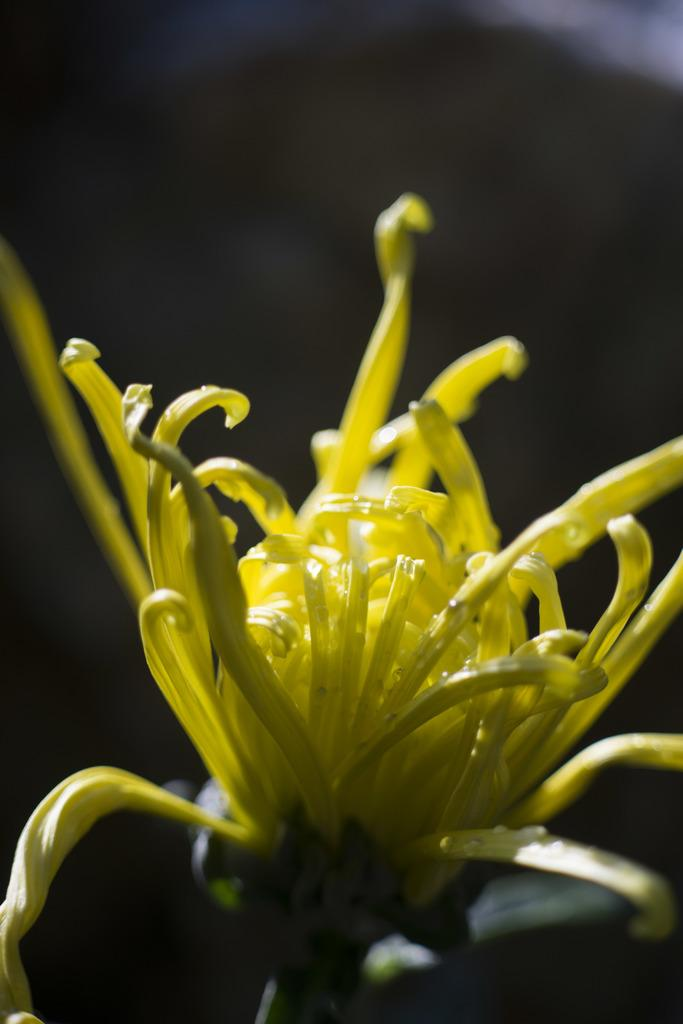What type of flower is present in the image? There is a yellow color flower in the image. What type of acoustics can be heard in the image? There is no sound or acoustics present in the image, as it is a still image of a yellow color flower. 